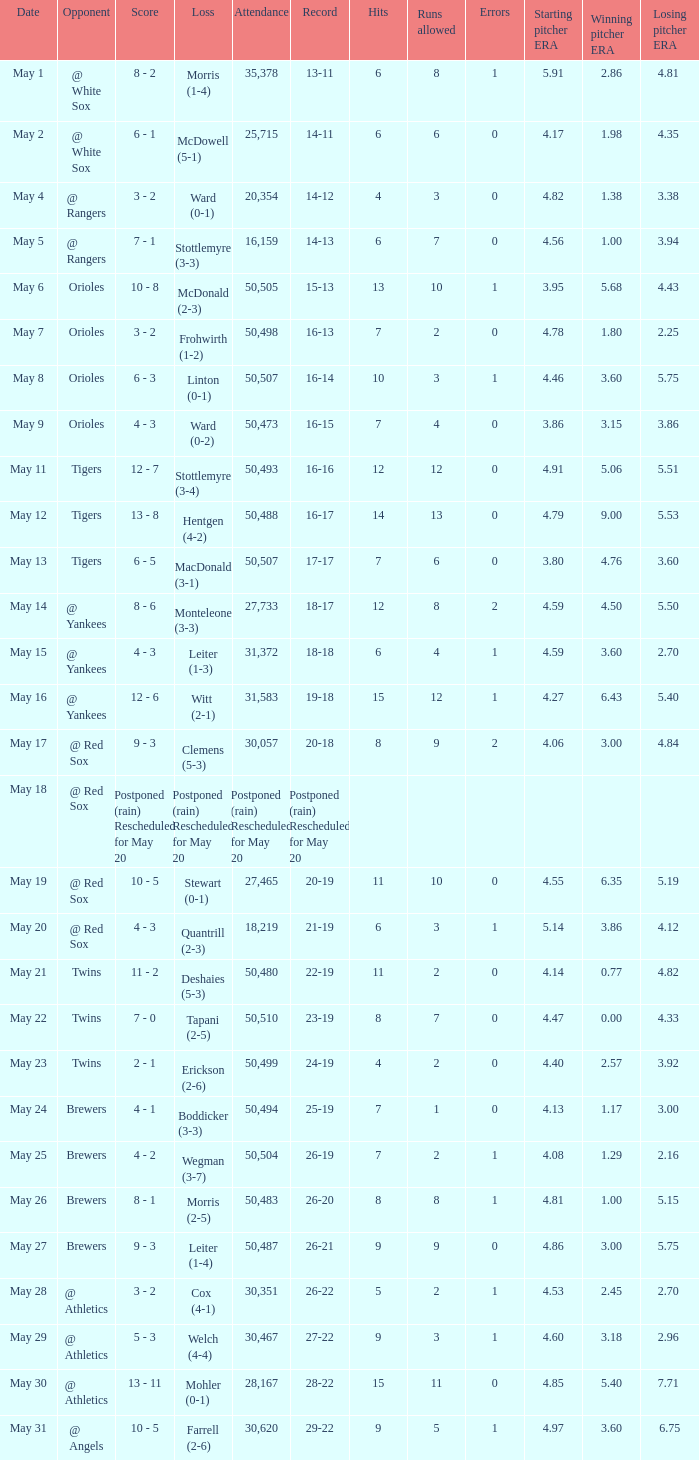What was the score of the game played on May 9? 4 - 3. 